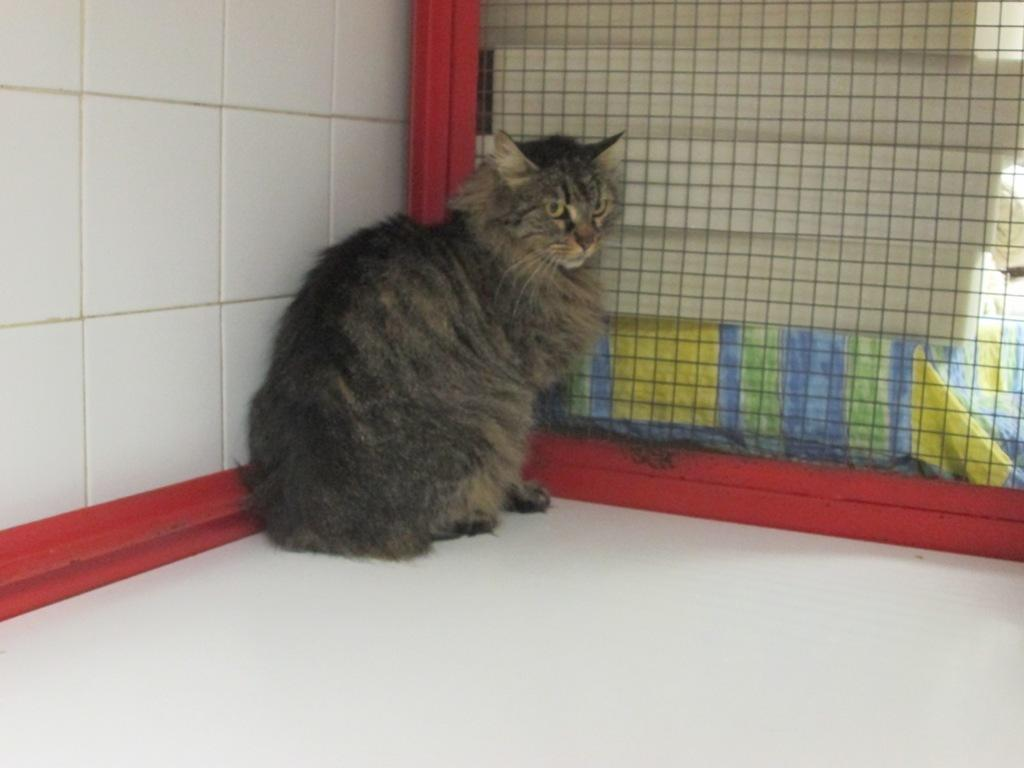What type of animal is in the image? There is a cat in the image. Where is the cat located in the image? The cat is on the white floor. What can be seen in the background of the image? There is a wall and a mesh in the background of the image. What type of insurance does the cat have in the image? There is no mention of insurance in the image, and the cat's insurance status cannot be determined. 